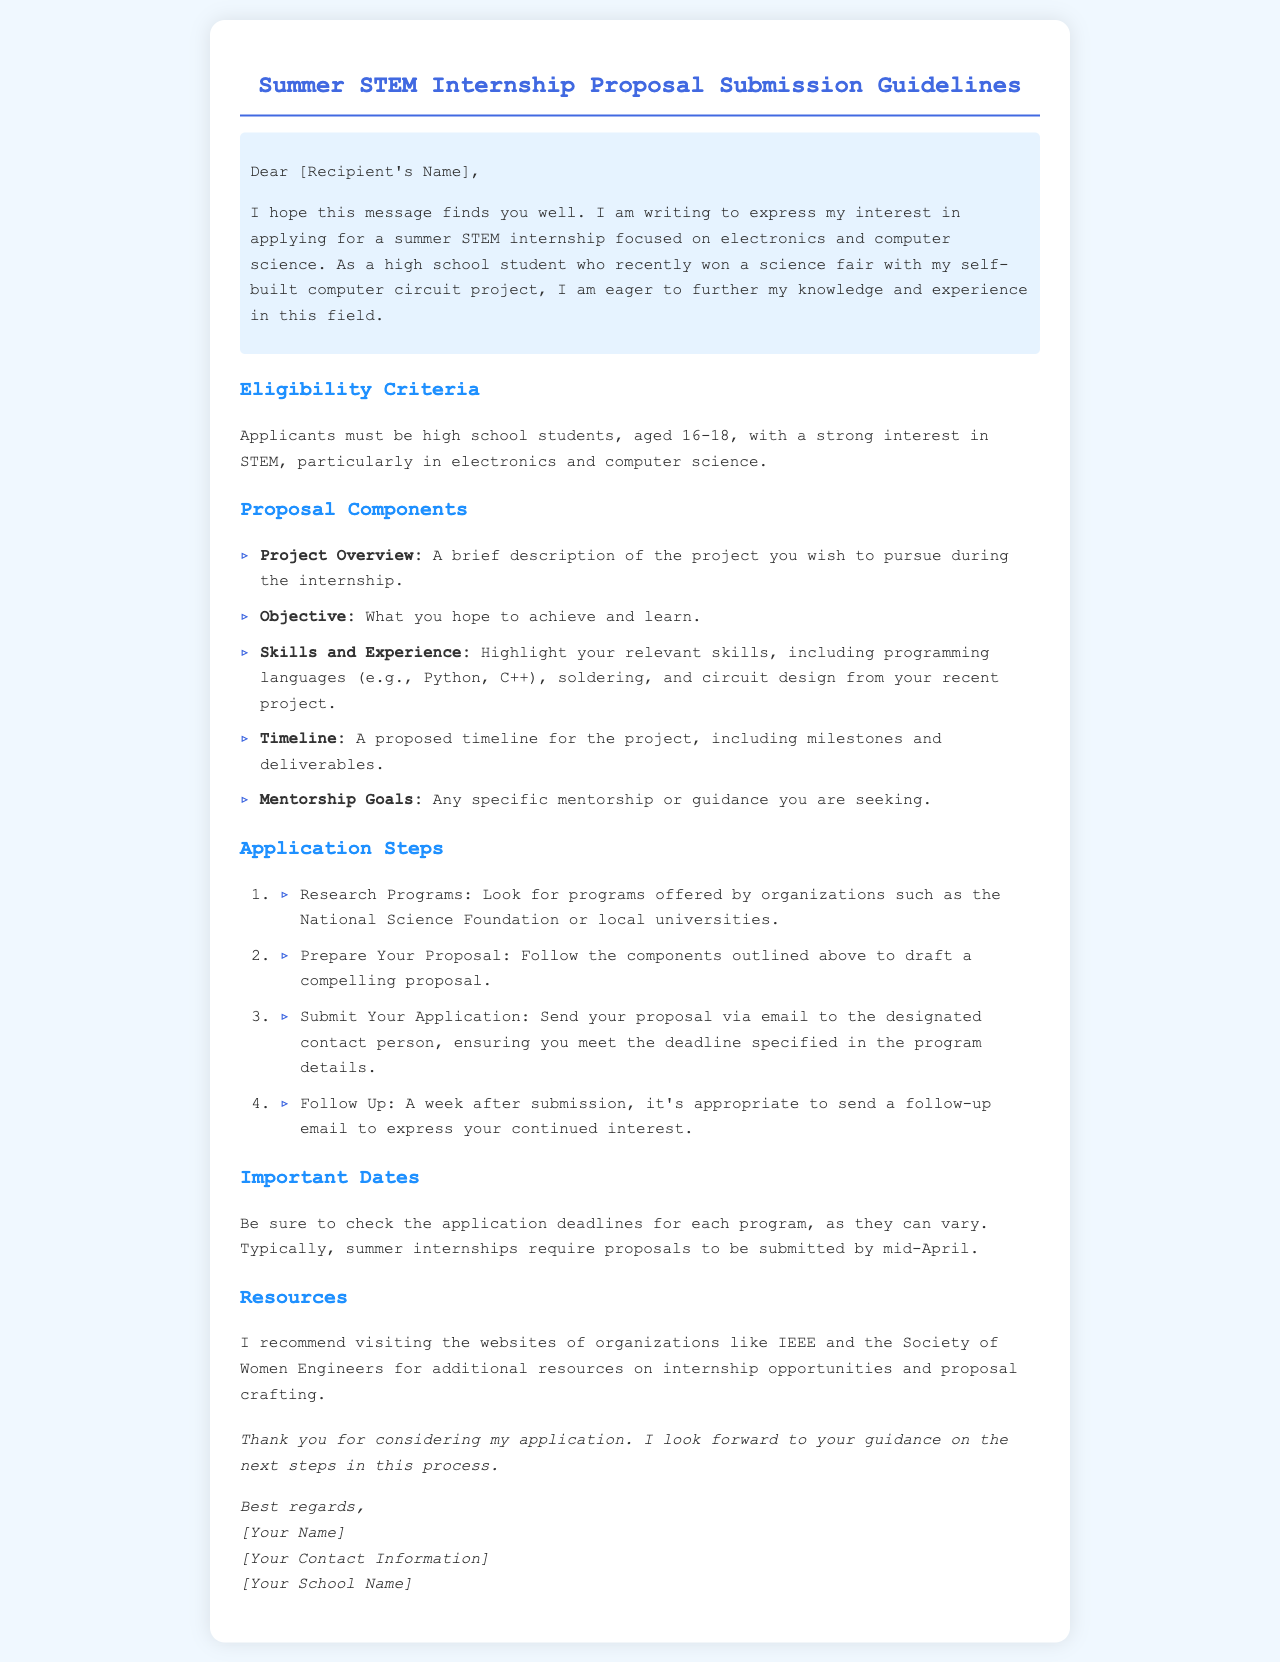What is the eligibility age for applicants? The eligibility criteria specify that applicants must be high school students aged 16-18.
Answer: 16-18 What organizations are mentioned for researching programs? The email mentions the National Science Foundation and local universities as places to look for programs.
Answer: National Science Foundation What is one component required in the proposal? The document lists "Project Overview" as one of the components that need to be included in the proposal.
Answer: Project Overview What is a key objective for applicants to detail in their proposal? The proposal requires applicants to clearly state what they hope to achieve and learn during the internship.
Answer: Objective When should proposals typically be submitted? The document suggests that summer internship proposals are typically due by mid-April.
Answer: Mid-April What is the first step in the application process? The application steps outline that the first step is to research programs.
Answer: Research Programs Which skills should applicants highlight in their proposals? Applicants are encouraged to highlight skills such as programming languages, soldering, and circuit design.
Answer: Programming languages, soldering, circuit design What should be included in the mentorship goals section? The mentorship goals section should include any specific mentorship or guidance sought by the applicant.
Answer: Specific mentorship or guidance What kind of email should be sent after submitting the proposal? It is appropriate to send a follow-up email to express continued interest one week after submission.
Answer: Follow-up email 